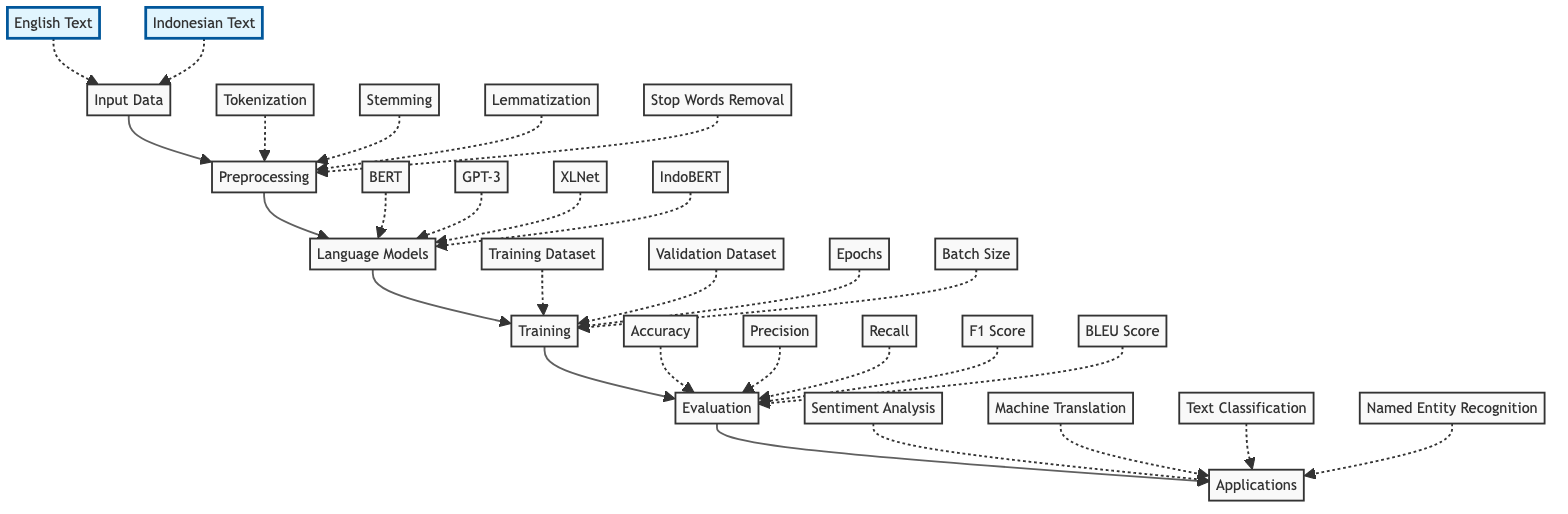What are the two types of input data? The diagram indicates two specific inputs for language models: English Text and Indonesian Text, which are both categorized under the Input Data node.
Answer: English Text, Indonesian Text How many preprocessing steps are there? The Preprocessing node lists four distinct steps: Tokenization, Stemming, Lemmatization, and Stop Words Removal, totaling to four preprocessing steps.
Answer: 4 Which language model is specifically designed for Indonesian text? Among the listed Language Models, IndoBERT is explicitly recognized as the model tailored for Indonesian text processing.
Answer: IndoBERT What is the first node in the flowchart? The flowchart begins with the Input Data node, which is the first element that the other processes rely on in the diagram.
Answer: Input Data Which evaluation metric is used for machine translation? The evaluation metric specifically associated with machine translation, as indicated in the Evaluation node, is the BLEU Score, which quantifies the quality of translations.
Answer: BLEU Score What is the relationship between Preprocessing and Input Data? The Preprocessing node directly follows the Input Data node in the diagram, indicating that preprocessing steps are applied to the input data received from the previous stage.
Answer: Directly follows What aspects are included in the Training process? The Training node outlines four key aspects: Training Dataset, Validation Dataset, Epochs, and Batch Size, which are crucial for the model training phase.
Answer: Training Dataset, Validation Dataset, Epochs, Batch Size Which model is known for text generation? In the diagram, GPT-3 is identified as a prominent model known for text generation tasks within the Language Models section.
Answer: GPT-3 Which application does Sentiment Analysis belong to? Sentiment Analysis is categorized under the Applications node, showing that it is one area where the language models are utilized for analysis tasks.
Answer: Applications 